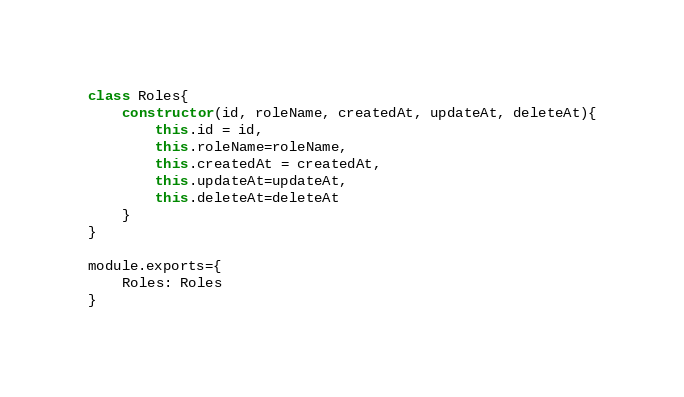Convert code to text. <code><loc_0><loc_0><loc_500><loc_500><_JavaScript_>class Roles{
    constructor(id, roleName, createdAt, updateAt, deleteAt){
        this.id = id,
        this.roleName=roleName,
        this.createdAt = createdAt,
        this.updateAt=updateAt,
        this.deleteAt=deleteAt
    }
}

module.exports={
    Roles: Roles
}</code> 